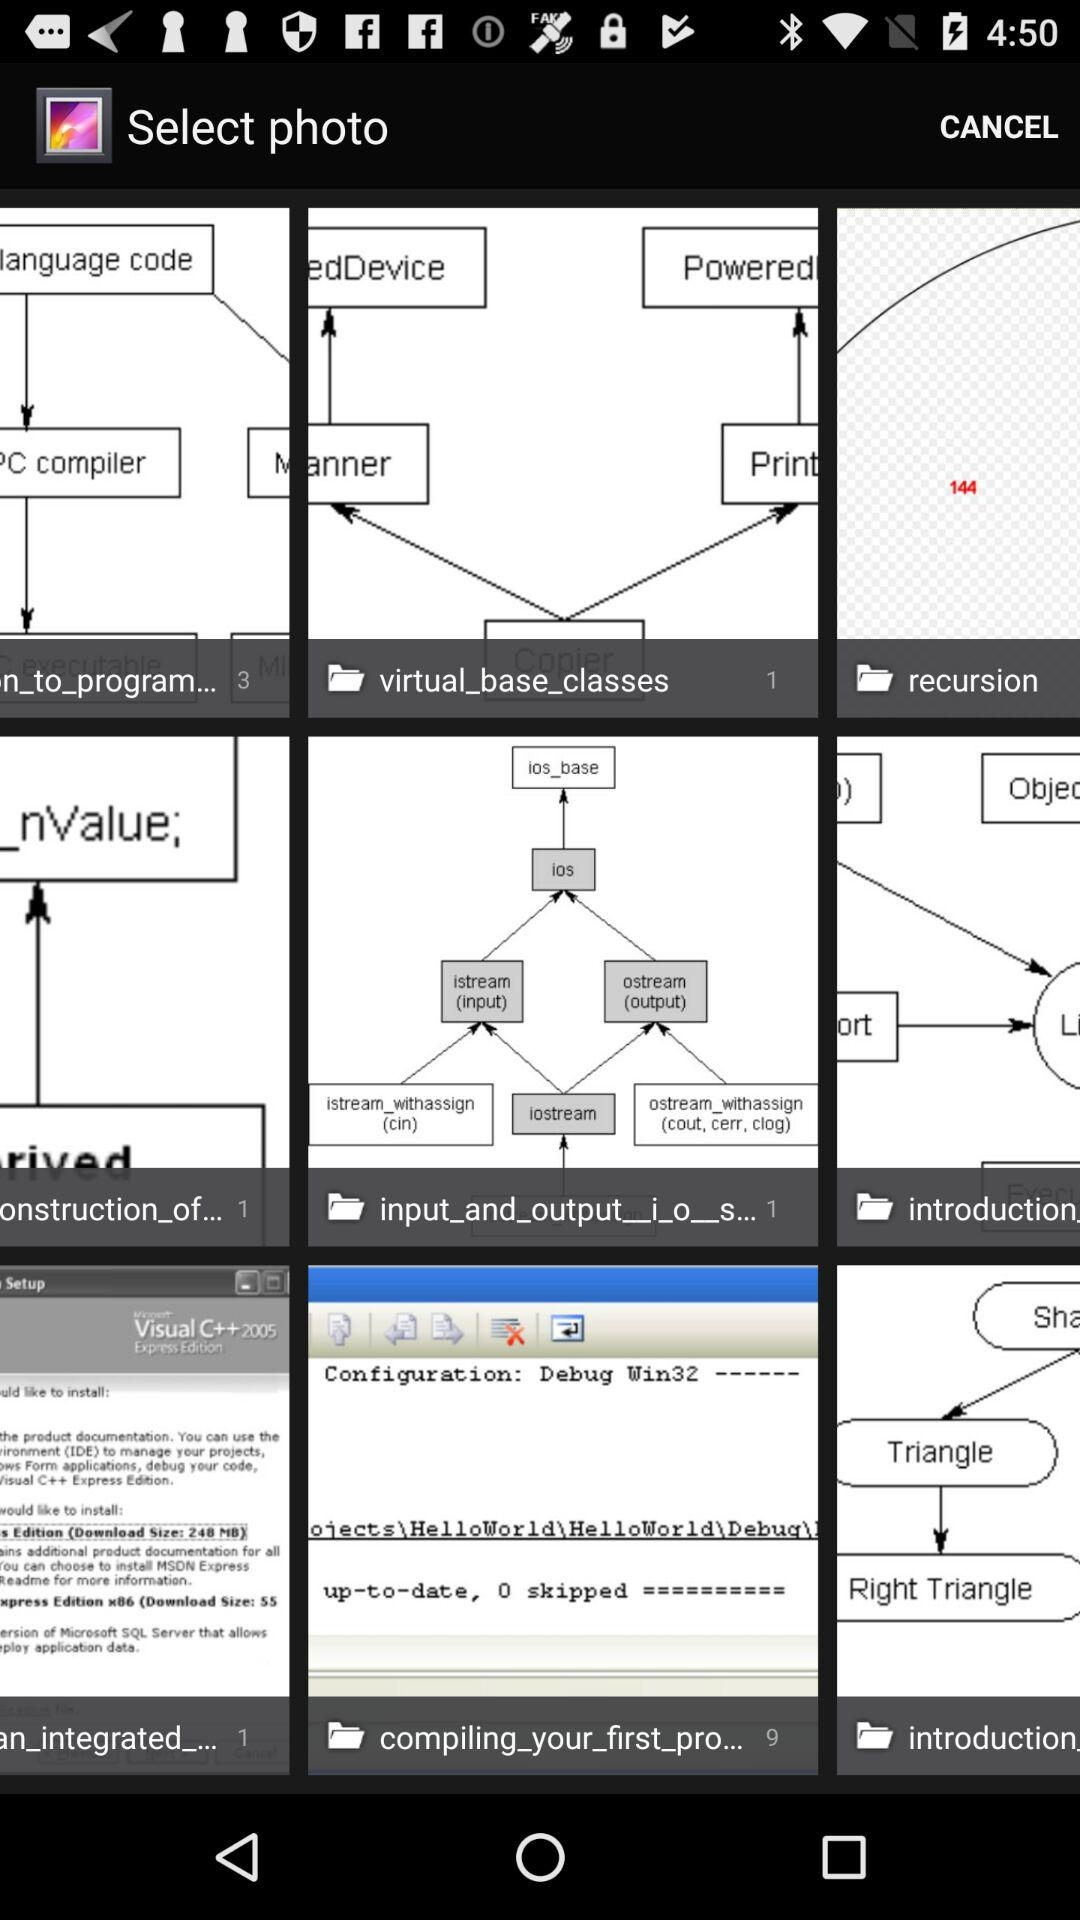How many photos are there in the folder "virtual_base_classes"? There is 1 photo in the "virtual_base_classes" folder. 